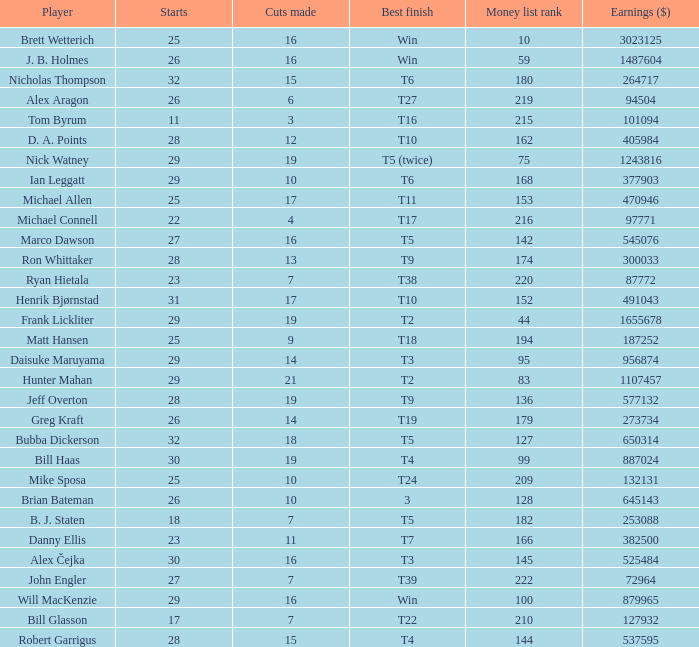What is the maximum money list rank for Matt Hansen? 194.0. 